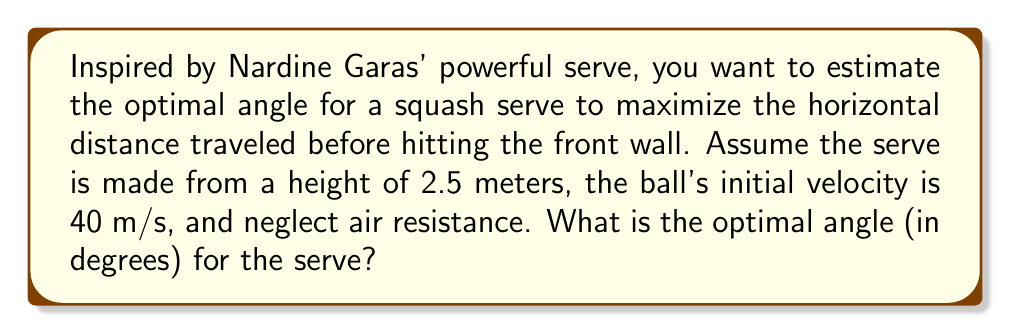Teach me how to tackle this problem. To solve this problem, we'll use principles of projectile motion and trigonometry. Let's approach this step-by-step:

1) The horizontal distance (R) traveled by a projectile launched at an angle θ with initial velocity v₀ is given by:

   $$R = \frac{v_0^2}{g} \sin(2\theta) \left(1 + \sqrt{1 + \frac{2gh}{v_0^2 \sin^2(\theta)}}\right)$$

   Where g is the acceleration due to gravity (9.8 m/s²) and h is the initial height.

2) To find the optimal angle, we need to maximize R. Mathematically, this occurs when:

   $$\frac{dR}{d\theta} = 0$$

3) Solving this equation analytically is complex, so we'll use a numerical approach. We can plot R vs θ and find the maximum:

[asy]
import graph;
size(200,150);

real v0 = 40;
real g = 9.8;
real h = 2.5;

real R(real theta) {
  return (v0^2/g)*sin(2*theta)*(1 + sqrt(1 + 2*g*h/(v0^2*sin(theta)^2)));
}

path graph = graph(R, 0, pi/2, n=1000);

draw(graph, blue);
xaxis("θ (radians)", 0, pi/2, Arrow);
yaxis("R (meters)", 0, 20, Arrow);

pair max = (0,0);
for (real theta = 0; theta <= pi/2; theta += 0.001) {
  pair p = (theta, R(theta));
  if (p.y > max.y) max = p;
}

dot(max, red);
label("Maximum", max, NE);
[/asy]

4) From the plot, we can see that the maximum occurs at approximately 0.68 radians.

5) Converting to degrees:

   $$\theta_{optimal} \approx 0.68 \times \frac{180}{\pi} \approx 39°$$

This result aligns with the well-known fact that the optimal launch angle for projectile motion from ground level is 45°. The slightly lower angle here is due to the initial height of 2.5 meters.
Answer: 39° 